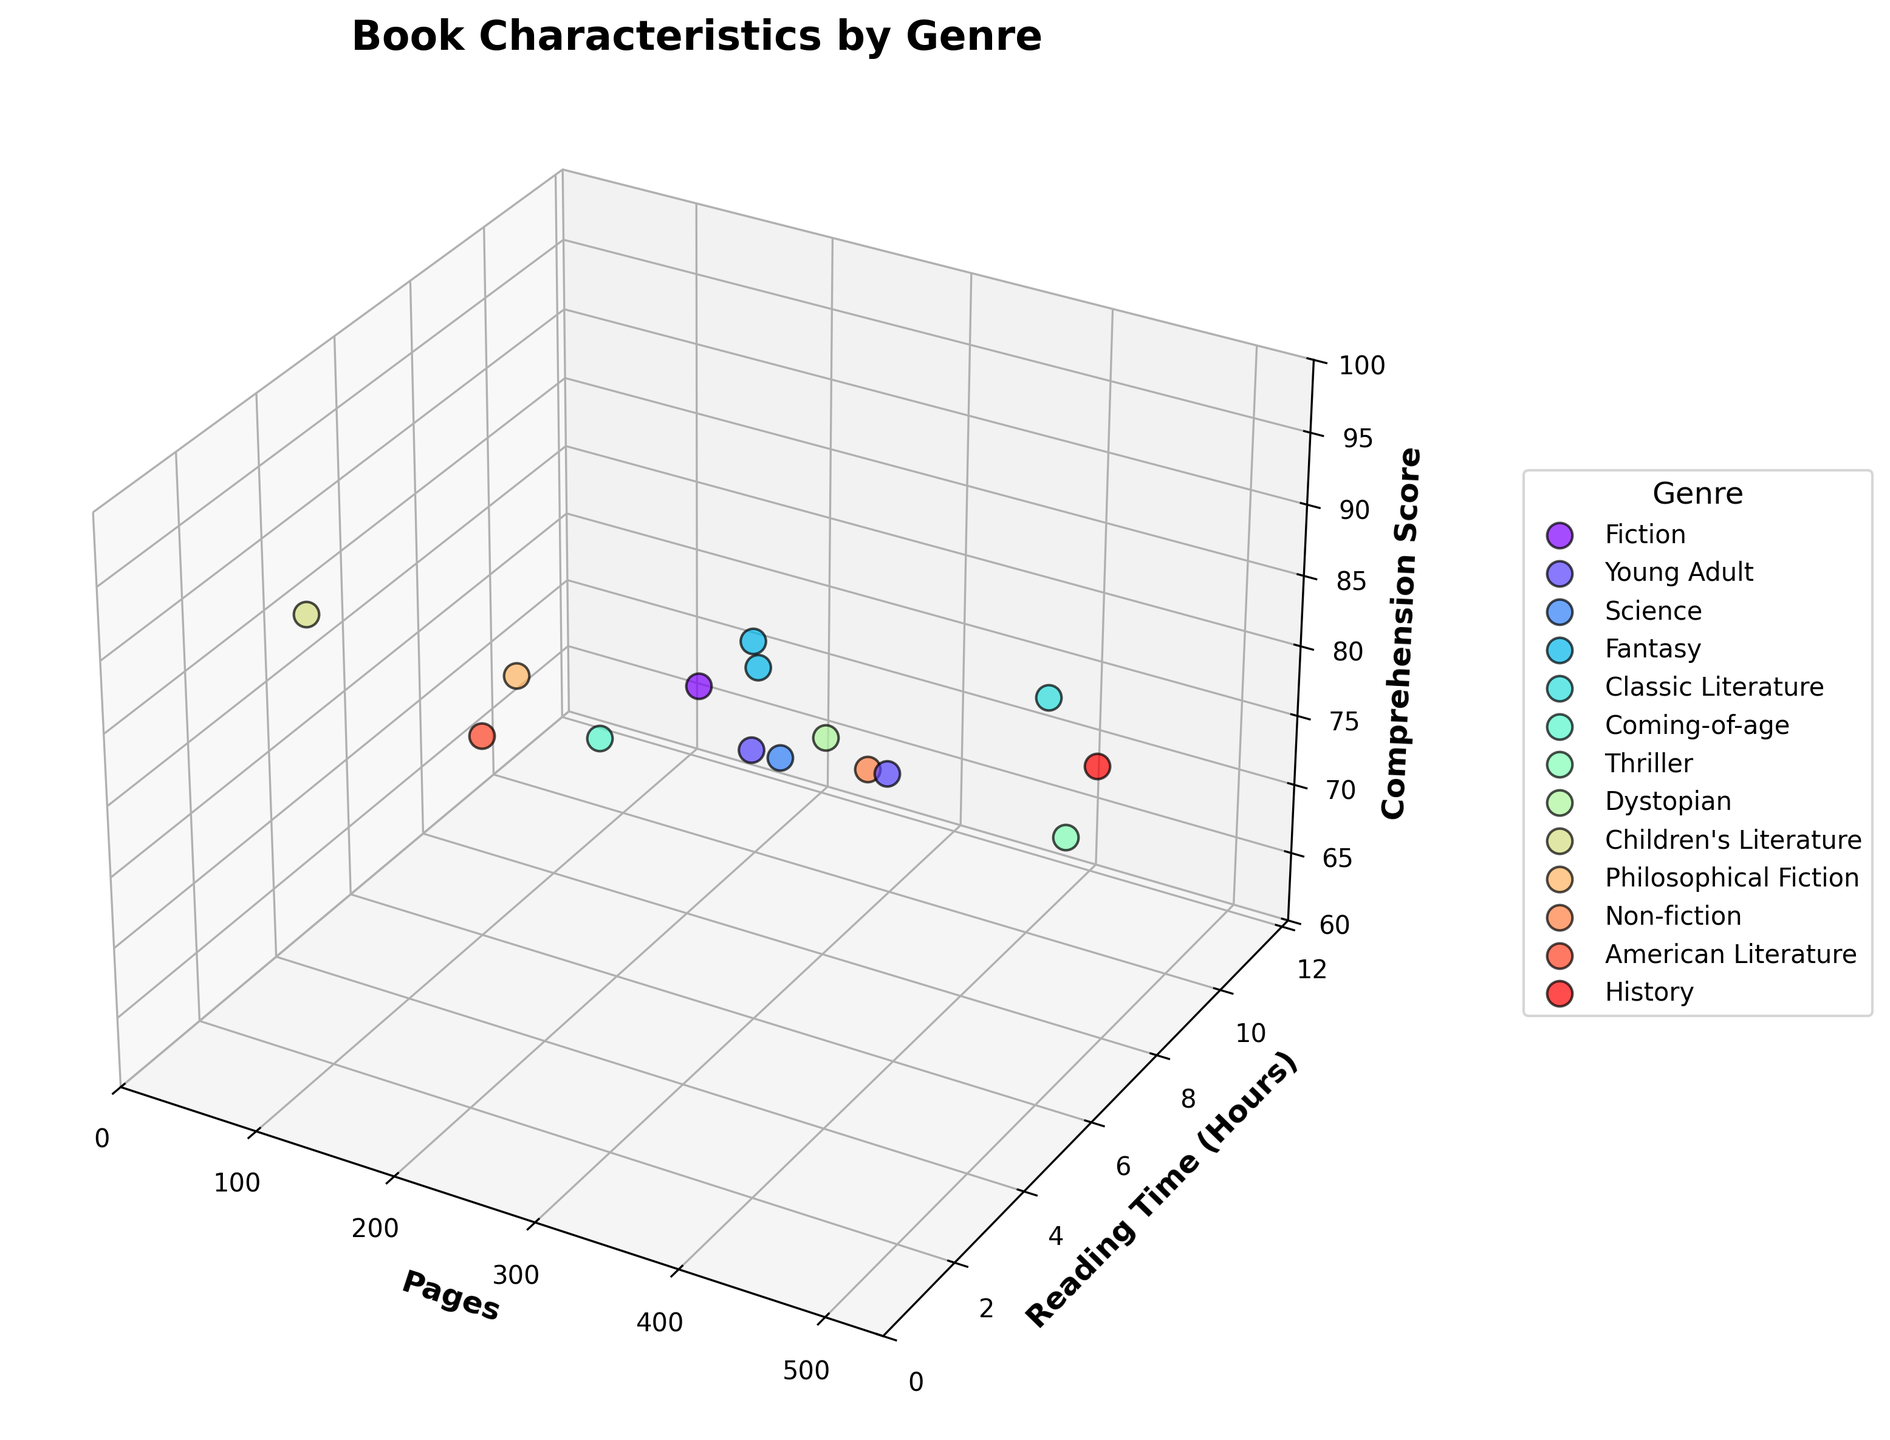What is the title of the 3D scatter plot? The title is displayed at the top of the plot. It is "Book Characteristics by Genre".
Answer: Book Characteristics by Genre What are the labels for the three axes? By looking at the axes labels, we can identify them as: Pages (x-axis), Reading Time (Hours) (y-axis), and Comprehension Score (z-axis).
Answer: Pages, Reading Time (Hours), Comprehension Score Which genre has the highest labeled comprehension score? By observing the highest point on the z-axis (Comprehension Score), we see that the data point for Children's Literature has the highest score with a Comprehension Score of 92.
Answer: Children's Literature How many genres are represented in the plot? The legend or color coding in the plot indicates the number of unique genres. Counting these categories, we can see there are eleven genres present.
Answer: 11 What is the range of the reading time axis? The y-axis (Reading Time in Hours) ranges from minimum 0 to slightly above the maximum value of 10.2, based on the tight layout and grid lines.
Answer: 0 to 12 Which book seems to take the longest reading time? The book with the highest value on the y-axis (Reading Time in Hours) is at 10.2 hours, which corresponds to "Sapiens: A Brief History of Humankind" in the History genre.
Answer: Sapiens: A Brief History of Humankind What can be inferred about the correlation between book length and reading time? By examining the scatter of the data points with respect to the x-axis (Pages) and y-axis (Reading Time in Hours), it appears that as the number of pages increases, the reading time also generally increases, indicating a positive correlation.
Answer: Positive correlation Which genre tends to have books with higher comprehension scores? By observing the vertical spread (z-axis) of data points for various genres, genres like Fantasy and Children's Literature show higher positions, indicating they generally have higher comprehension scores.
Answer: Fantasy and Children's Literature Are there any genres that cluster closely together in terms of all three variables (Pages, Reading Time, Comprehension Score)? By observing the clustering patterns in the plot, Fiction, Young Adult, and Fantasy genres have clustered points, implying that books within these genres tend to have similar page numbers, reading times, and comprehension scores. They are closely grouped in terms of the 3D space.
Answer: Fiction, Young Adult, Fantasy Compare the comprehension scores of Harry Potter and the Sorcerer's Stone and To Kill a Mockingbird. Harry Potter and the Sorcerer's Stone and To Kill a Mockingbird can be found in the plot by their respective genres. Harry Potter and the Sorcerer's Stone (Fantasy) has a higher z-axis point (88) compared to To Kill a Mockingbird (Fiction) with a score of 85.
Answer: Harry Potter and the Sorcerer's Stone has a higher comprehension score (88 vs 85) 